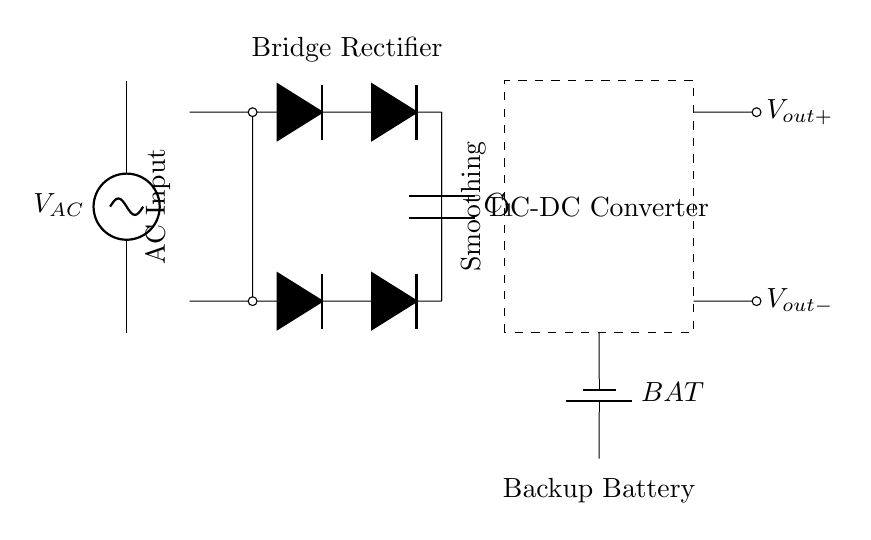What is the type of power source used in this circuit? The power source is a voltage source indicated by the symbol $V_{AC}$, which provides alternating current (AC) to the circuit.
Answer: Voltage source What components are present in the bridge rectifier section? The bridge rectifier consists of four diodes, as shown in the diagram with symbols labeled as $D*$. They are arranged in a specific configuration to convert AC to DC.
Answer: Four diodes What is the function of capacitor C1 in this circuit? Capacitor C1 serves to smooth out the DC output voltage by filtering out ripples from the rectified voltage, providing a more stable output.
Answer: Smoothing How many outputs does the circuit have? The circuit features two outputs labeled $V_{out+}$ and $V_{out-}$, which provide the positive and negative outputs of the DC supply respectively.
Answer: Two outputs What does the dashed box in the circuit represent? The dashed box represents the DC-DC converter which is responsible for regulating the output voltage and converting DC voltage from the battery to a usable level for the load.
Answer: DC-DC Converter What is the role of the battery in this circuit? The battery acts as a backup power source that provides energy when the AC supply is interrupted, ensuring uninterruptible power supply (UPS) functionality.
Answer: Backup power source 